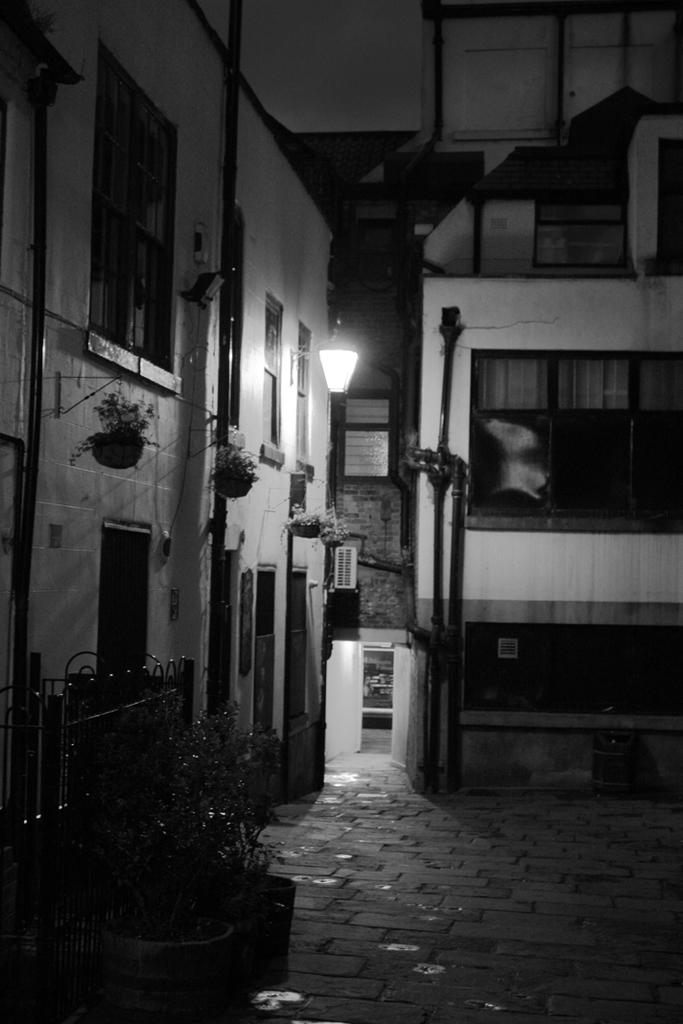What type of plants can be seen in the image? There are house plants in the image. What type of structures are visible in the image? There are buildings with windows in the image. What type of infrastructure is visible in the image? There are pipes visible in the image. What type of vertical structure is present in the image? There is a pole in the image. What type of illumination is present in the image? There is a light in the image. What type of pigs can be seen in the image? There are no pigs present in the image. What type of bat is flying around the light in the image? There is no bat present in the image. 